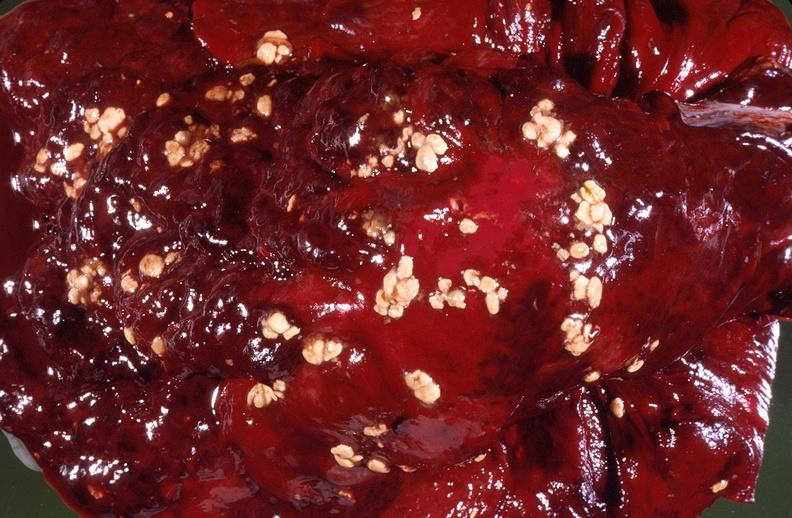does this image show pleural cavity, actinomyces sulfur granules?
Answer the question using a single word or phrase. Yes 